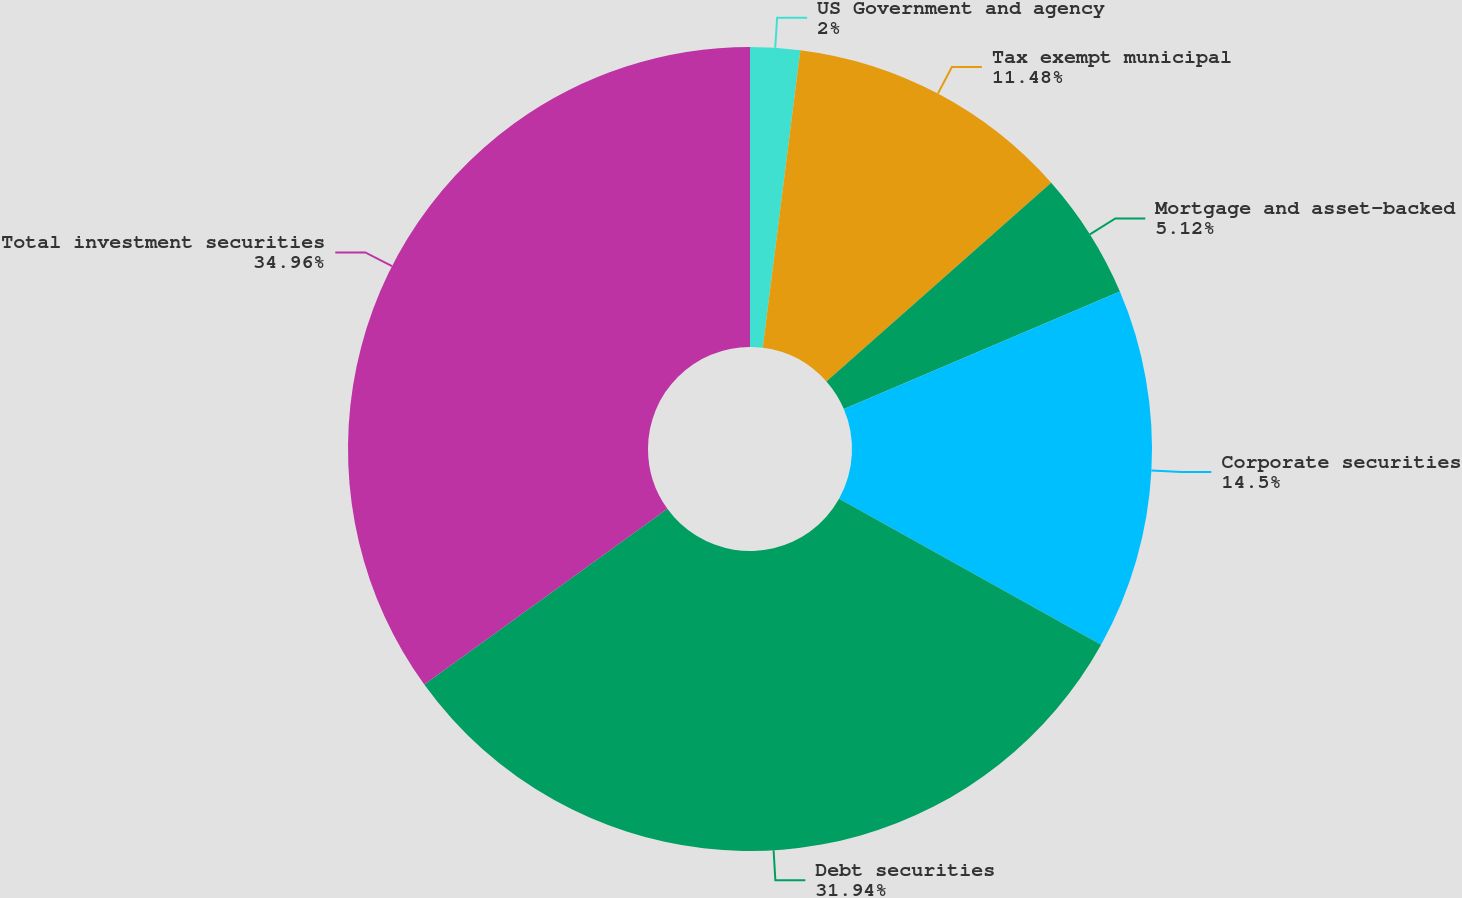<chart> <loc_0><loc_0><loc_500><loc_500><pie_chart><fcel>US Government and agency<fcel>Tax exempt municipal<fcel>Mortgage and asset-backed<fcel>Corporate securities<fcel>Debt securities<fcel>Total investment securities<nl><fcel>2.0%<fcel>11.48%<fcel>5.12%<fcel>14.5%<fcel>31.94%<fcel>34.97%<nl></chart> 